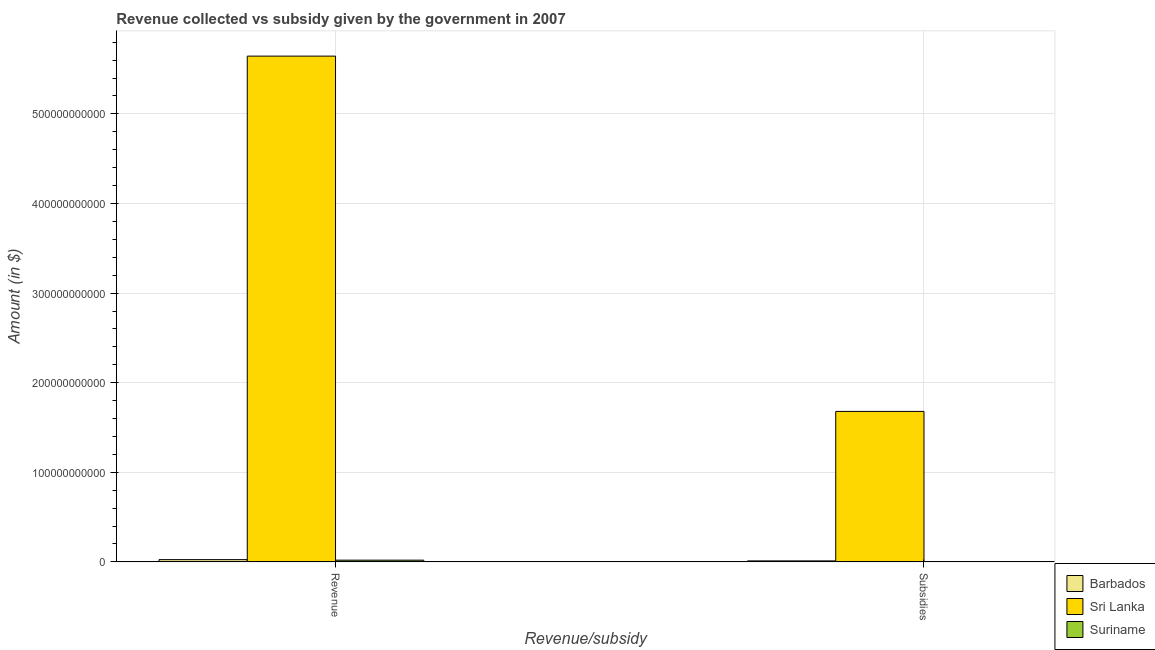How many different coloured bars are there?
Ensure brevity in your answer.  3. How many groups of bars are there?
Provide a succinct answer. 2. Are the number of bars per tick equal to the number of legend labels?
Keep it short and to the point. Yes. What is the label of the 1st group of bars from the left?
Provide a succinct answer. Revenue. What is the amount of subsidies given in Suriname?
Your answer should be very brief. 3.92e+08. Across all countries, what is the maximum amount of revenue collected?
Ensure brevity in your answer.  5.65e+11. Across all countries, what is the minimum amount of subsidies given?
Give a very brief answer. 3.92e+08. In which country was the amount of subsidies given maximum?
Give a very brief answer. Sri Lanka. In which country was the amount of revenue collected minimum?
Offer a terse response. Suriname. What is the total amount of subsidies given in the graph?
Offer a very short reply. 1.69e+11. What is the difference between the amount of revenue collected in Suriname and that in Barbados?
Offer a terse response. -5.85e+08. What is the difference between the amount of revenue collected in Suriname and the amount of subsidies given in Barbados?
Your response must be concise. 8.01e+08. What is the average amount of revenue collected per country?
Provide a short and direct response. 1.90e+11. What is the difference between the amount of subsidies given and amount of revenue collected in Barbados?
Keep it short and to the point. -1.39e+09. In how many countries, is the amount of subsidies given greater than 260000000000 $?
Give a very brief answer. 0. What is the ratio of the amount of subsidies given in Suriname to that in Sri Lanka?
Your answer should be very brief. 0. Is the amount of subsidies given in Sri Lanka less than that in Suriname?
Give a very brief answer. No. What does the 2nd bar from the left in Subsidies represents?
Offer a very short reply. Sri Lanka. What does the 1st bar from the right in Subsidies represents?
Keep it short and to the point. Suriname. How many bars are there?
Your answer should be very brief. 6. How many countries are there in the graph?
Your response must be concise. 3. What is the difference between two consecutive major ticks on the Y-axis?
Ensure brevity in your answer.  1.00e+11. Are the values on the major ticks of Y-axis written in scientific E-notation?
Make the answer very short. No. Does the graph contain any zero values?
Offer a very short reply. No. Does the graph contain grids?
Give a very brief answer. Yes. What is the title of the graph?
Provide a succinct answer. Revenue collected vs subsidy given by the government in 2007. Does "Philippines" appear as one of the legend labels in the graph?
Ensure brevity in your answer.  No. What is the label or title of the X-axis?
Your answer should be very brief. Revenue/subsidy. What is the label or title of the Y-axis?
Keep it short and to the point. Amount (in $). What is the Amount (in $) in Barbados in Revenue?
Keep it short and to the point. 2.53e+09. What is the Amount (in $) of Sri Lanka in Revenue?
Provide a short and direct response. 5.65e+11. What is the Amount (in $) of Suriname in Revenue?
Offer a terse response. 1.94e+09. What is the Amount (in $) of Barbados in Subsidies?
Your response must be concise. 1.14e+09. What is the Amount (in $) of Sri Lanka in Subsidies?
Provide a succinct answer. 1.68e+11. What is the Amount (in $) of Suriname in Subsidies?
Keep it short and to the point. 3.92e+08. Across all Revenue/subsidy, what is the maximum Amount (in $) of Barbados?
Your response must be concise. 2.53e+09. Across all Revenue/subsidy, what is the maximum Amount (in $) in Sri Lanka?
Provide a short and direct response. 5.65e+11. Across all Revenue/subsidy, what is the maximum Amount (in $) in Suriname?
Keep it short and to the point. 1.94e+09. Across all Revenue/subsidy, what is the minimum Amount (in $) of Barbados?
Provide a short and direct response. 1.14e+09. Across all Revenue/subsidy, what is the minimum Amount (in $) in Sri Lanka?
Ensure brevity in your answer.  1.68e+11. Across all Revenue/subsidy, what is the minimum Amount (in $) of Suriname?
Offer a terse response. 3.92e+08. What is the total Amount (in $) in Barbados in the graph?
Offer a terse response. 3.67e+09. What is the total Amount (in $) of Sri Lanka in the graph?
Provide a short and direct response. 7.32e+11. What is the total Amount (in $) in Suriname in the graph?
Your answer should be very brief. 2.34e+09. What is the difference between the Amount (in $) in Barbados in Revenue and that in Subsidies?
Your answer should be very brief. 1.39e+09. What is the difference between the Amount (in $) in Sri Lanka in Revenue and that in Subsidies?
Provide a succinct answer. 3.97e+11. What is the difference between the Amount (in $) of Suriname in Revenue and that in Subsidies?
Your answer should be very brief. 1.55e+09. What is the difference between the Amount (in $) in Barbados in Revenue and the Amount (in $) in Sri Lanka in Subsidies?
Ensure brevity in your answer.  -1.65e+11. What is the difference between the Amount (in $) of Barbados in Revenue and the Amount (in $) of Suriname in Subsidies?
Make the answer very short. 2.14e+09. What is the difference between the Amount (in $) in Sri Lanka in Revenue and the Amount (in $) in Suriname in Subsidies?
Make the answer very short. 5.64e+11. What is the average Amount (in $) of Barbados per Revenue/subsidy?
Keep it short and to the point. 1.84e+09. What is the average Amount (in $) of Sri Lanka per Revenue/subsidy?
Offer a terse response. 3.66e+11. What is the average Amount (in $) of Suriname per Revenue/subsidy?
Ensure brevity in your answer.  1.17e+09. What is the difference between the Amount (in $) in Barbados and Amount (in $) in Sri Lanka in Revenue?
Provide a succinct answer. -5.62e+11. What is the difference between the Amount (in $) of Barbados and Amount (in $) of Suriname in Revenue?
Provide a succinct answer. 5.85e+08. What is the difference between the Amount (in $) of Sri Lanka and Amount (in $) of Suriname in Revenue?
Provide a succinct answer. 5.63e+11. What is the difference between the Amount (in $) of Barbados and Amount (in $) of Sri Lanka in Subsidies?
Make the answer very short. -1.67e+11. What is the difference between the Amount (in $) in Barbados and Amount (in $) in Suriname in Subsidies?
Ensure brevity in your answer.  7.52e+08. What is the difference between the Amount (in $) in Sri Lanka and Amount (in $) in Suriname in Subsidies?
Your response must be concise. 1.68e+11. What is the ratio of the Amount (in $) in Barbados in Revenue to that in Subsidies?
Offer a very short reply. 2.21. What is the ratio of the Amount (in $) in Sri Lanka in Revenue to that in Subsidies?
Offer a very short reply. 3.36. What is the ratio of the Amount (in $) in Suriname in Revenue to that in Subsidies?
Offer a very short reply. 4.96. What is the difference between the highest and the second highest Amount (in $) in Barbados?
Make the answer very short. 1.39e+09. What is the difference between the highest and the second highest Amount (in $) of Sri Lanka?
Keep it short and to the point. 3.97e+11. What is the difference between the highest and the second highest Amount (in $) in Suriname?
Make the answer very short. 1.55e+09. What is the difference between the highest and the lowest Amount (in $) of Barbados?
Provide a succinct answer. 1.39e+09. What is the difference between the highest and the lowest Amount (in $) of Sri Lanka?
Make the answer very short. 3.97e+11. What is the difference between the highest and the lowest Amount (in $) in Suriname?
Your answer should be very brief. 1.55e+09. 